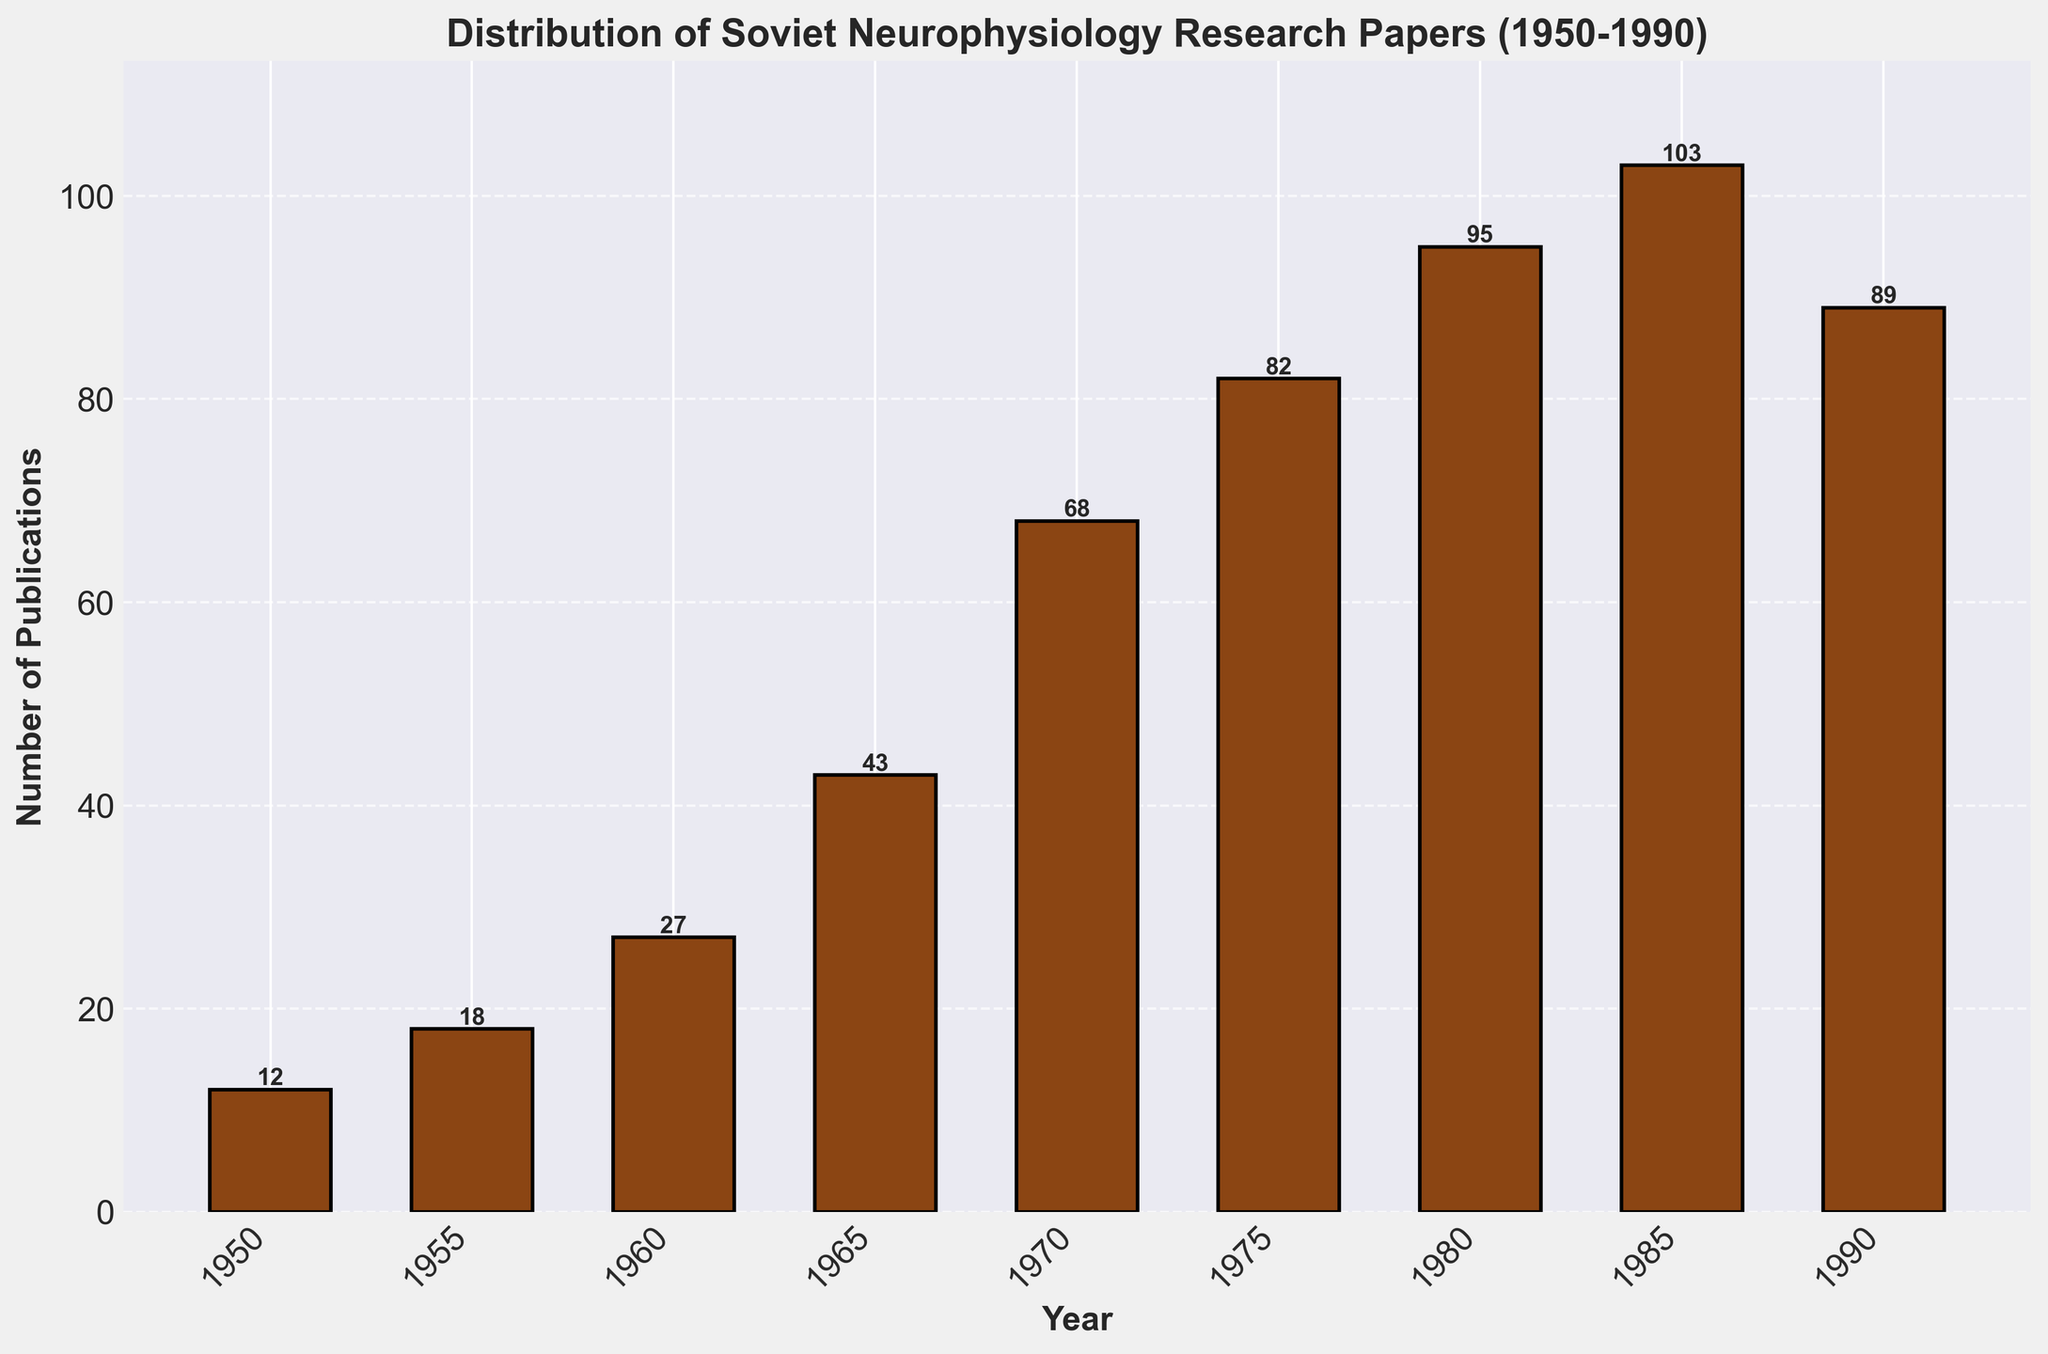What's the title of the figure? The title is located at the top of the figure and usually indicates what the data represents. In this case, it states "Distribution of Soviet Neurophysiology Research Papers (1950-1990)."
Answer: Distribution of Soviet Neurophysiology Research Papers (1950-1990) What are the labels on the x-axis and y-axis? The labels on the x-axis and y-axis provide context for the values displayed on the axes. Here, the x-axis is labeled "Year," and the y-axis is labeled "Number of Publications."
Answer: Year; Number of Publications Which year had the highest number of publications? To identify the year with the highest number of publications, look for the tallest bar in the histogram. The tallest bar corresponds to the year 1985 with 103 publications.
Answer: 1985 What color are the bars in the histogram? The color of the bars is visually apparent from the histogram and is described as brown (#8B4513). This color gives a warm, historical feel to the plot.
Answer: Brown How many publications were there in 1970? Find the bar that corresponds to the year 1970 and read the height of this bar. According to the figure, there were 68 publications in 1970.
Answer: 68 What's the total number of publications from the years 1960, 1970, and 1980 combined? Add the number of publications for each specified year: 27 (1960) + 68 (1970) + 95 (1980) = 190 publications.
Answer: 190 How did the number of publications change from 1955 to 1965? To determine the change, subtract the number of publications in 1955 from the number in 1965: 43 (1965) - 18 (1955) = 25 publications increased.
Answer: Increased by 25 What is the average number of publications per recorded year? To find the average, sum all the publication numbers and divide them by the number of years: (12 + 18 + 27 + 43 + 68 + 82 + 95 + 103 + 89) / 9 = 59.66 (rounded to two decimal places).
Answer: 59.66 From visual analysis, does the trend of publications seem to increase, decrease, or remain constant over the period? Observation of the overall pattern from left to right in the histogram indicates a general upward trend until 1985, followed by a slight decline in 1990.
Answer: Increase until 1985, then slight decrease in 1990 